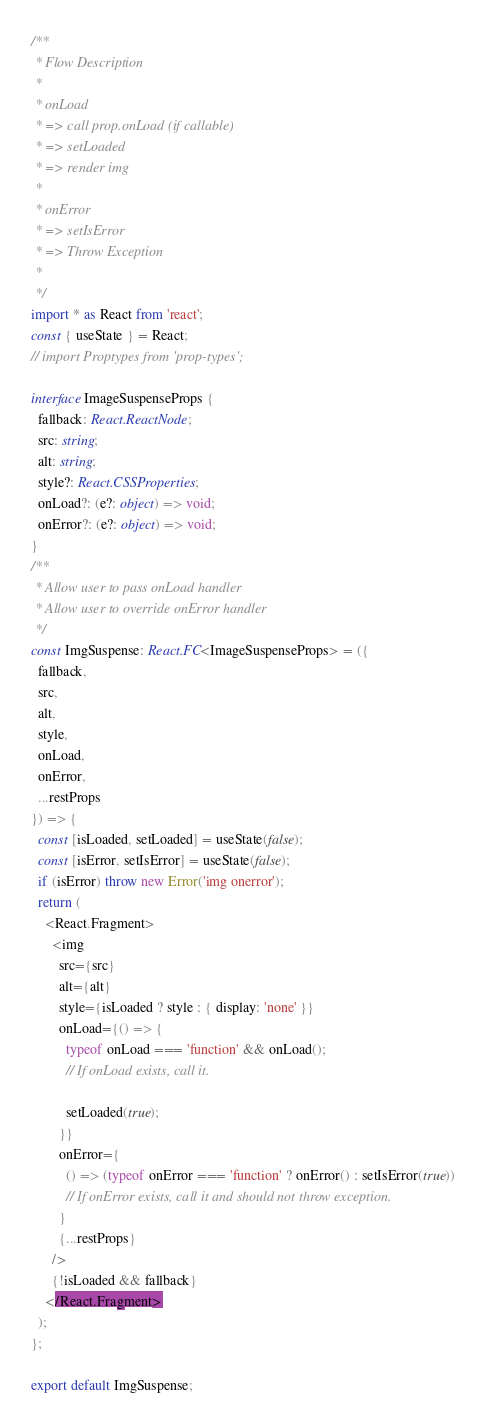<code> <loc_0><loc_0><loc_500><loc_500><_TypeScript_>/**
 * Flow Description
 *
 * onLoad
 * => call prop.onLoad (if callable)
 * => setLoaded
 * => render img
 *
 * onError
 * => setIsError
 * => Throw Exception
 *
 */
import * as React from 'react';
const { useState } = React;
// import Proptypes from 'prop-types';

interface ImageSuspenseProps {
  fallback: React.ReactNode;
  src: string;
  alt: string;
  style?: React.CSSProperties;
  onLoad?: (e?: object) => void;
  onError?: (e?: object) => void;
}
/**
 * Allow user to pass onLoad handler
 * Allow user to override onError handler
 */
const ImgSuspense: React.FC<ImageSuspenseProps> = ({
  fallback,
  src,
  alt,
  style,
  onLoad,
  onError,
  ...restProps
}) => {
  const [isLoaded, setLoaded] = useState(false);
  const [isError, setIsError] = useState(false);
  if (isError) throw new Error('img onerror');
  return (
    <React.Fragment>
      <img
        src={src}
        alt={alt}
        style={isLoaded ? style : { display: 'none' }}
        onLoad={() => {
          typeof onLoad === 'function' && onLoad();
          // If onLoad exists, call it.

          setLoaded(true);
        }}
        onError={
          () => (typeof onError === 'function' ? onError() : setIsError(true))
          // If onError exists, call it and should not throw exception.
        }
        {...restProps}
      />
      {!isLoaded && fallback}
    </React.Fragment>
  );
};

export default ImgSuspense;
</code> 